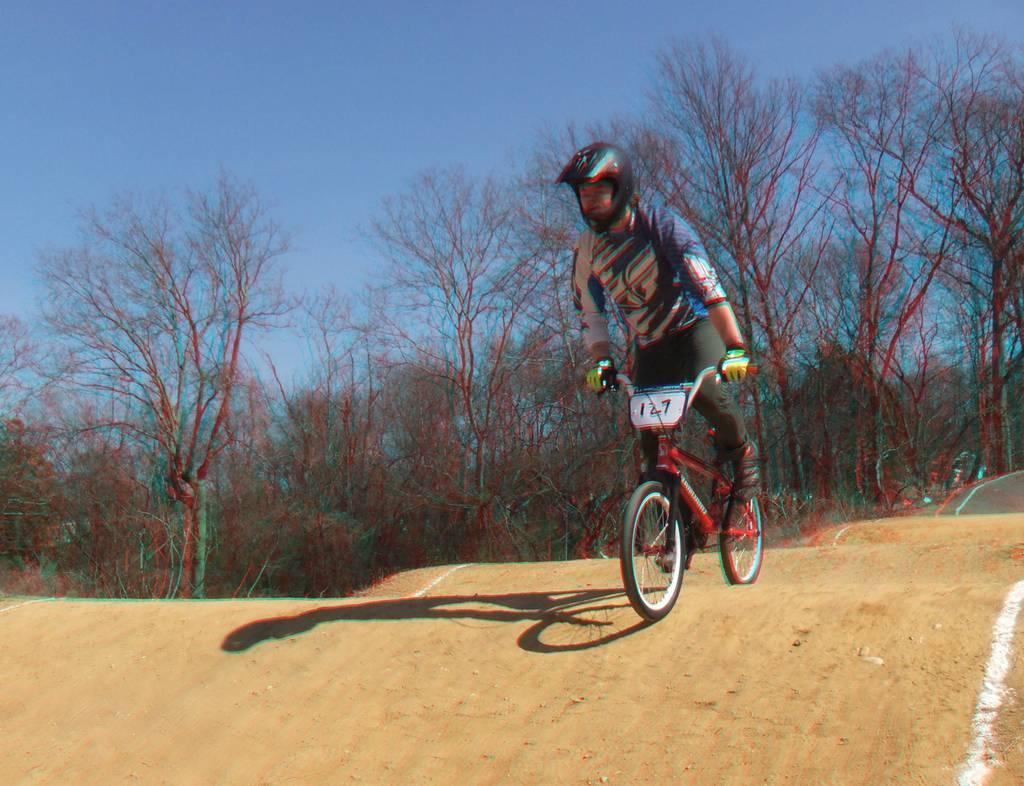Could you give a brief overview of what you see in this image? In this picture I can see a person riding the bicycle. I can see trees in the background. I can see the sky is clear. 